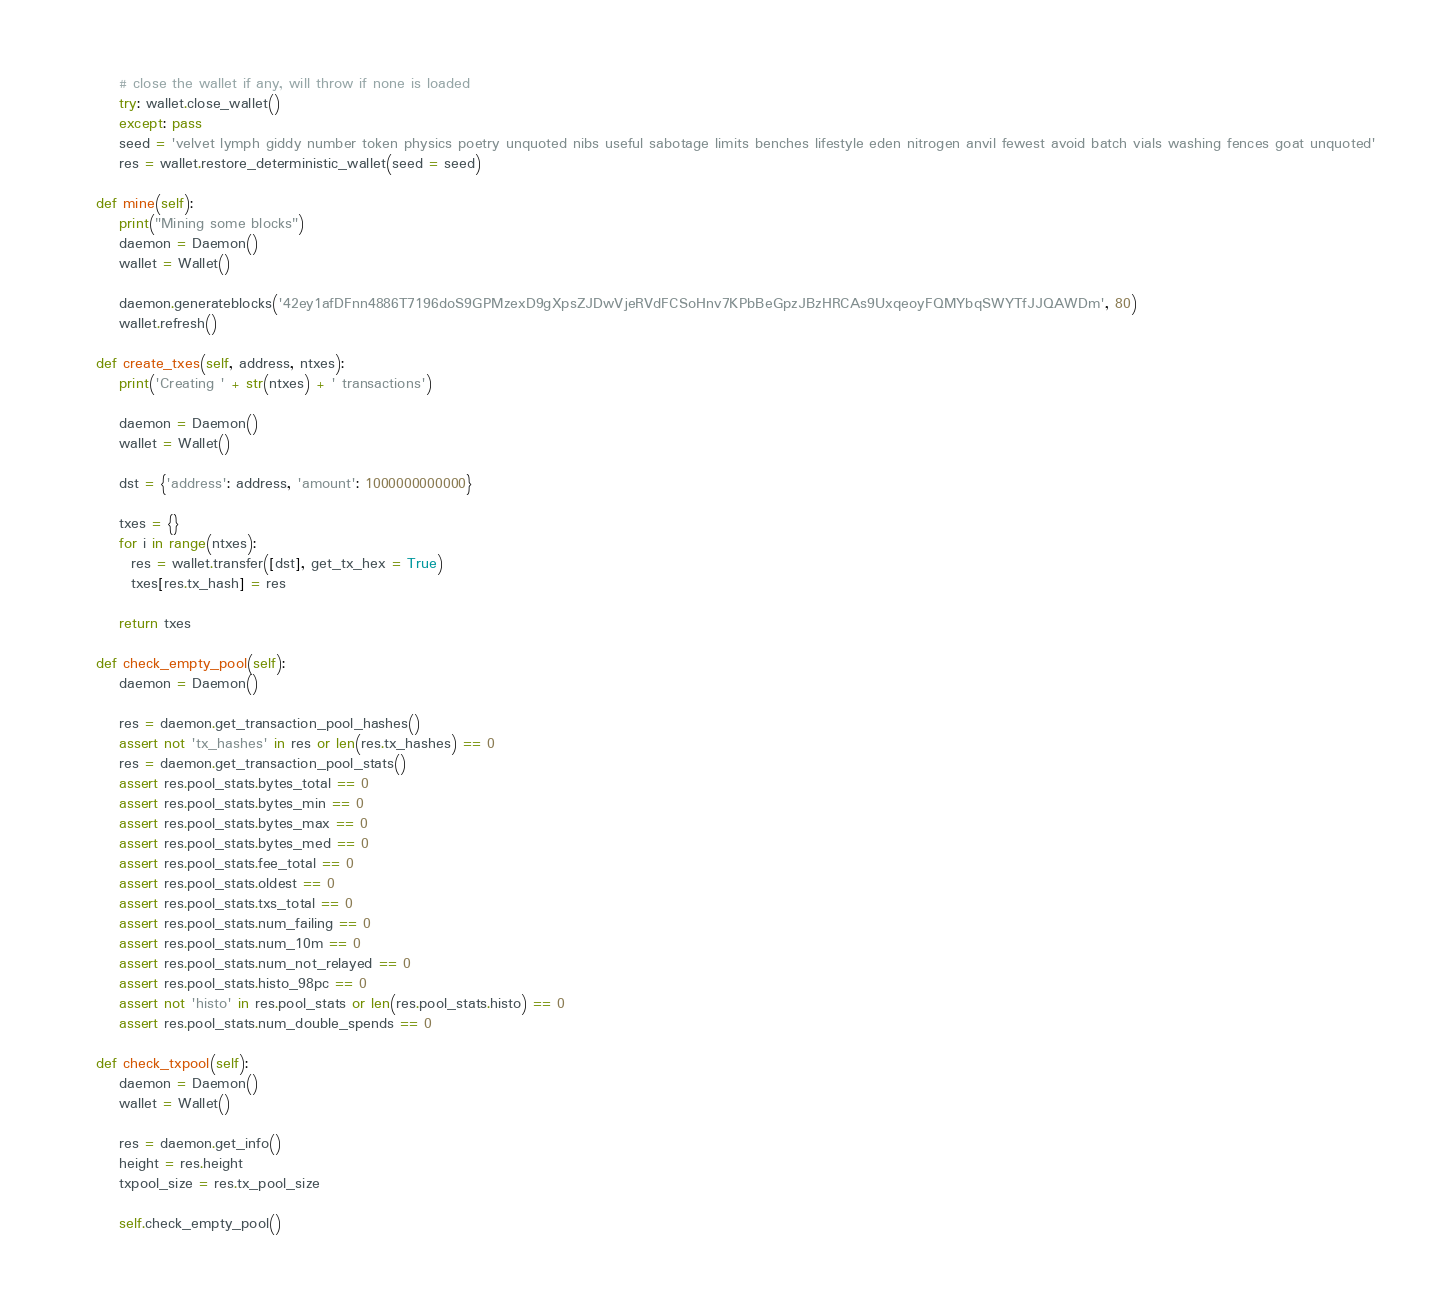Convert code to text. <code><loc_0><loc_0><loc_500><loc_500><_Python_>        # close the wallet if any, will throw if none is loaded
        try: wallet.close_wallet()
        except: pass
        seed = 'velvet lymph giddy number token physics poetry unquoted nibs useful sabotage limits benches lifestyle eden nitrogen anvil fewest avoid batch vials washing fences goat unquoted'
        res = wallet.restore_deterministic_wallet(seed = seed)

    def mine(self):
        print("Mining some blocks")
        daemon = Daemon()
        wallet = Wallet()

        daemon.generateblocks('42ey1afDFnn4886T7196doS9GPMzexD9gXpsZJDwVjeRVdFCSoHnv7KPbBeGpzJBzHRCAs9UxqeoyFQMYbqSWYTfJJQAWDm', 80)
        wallet.refresh()

    def create_txes(self, address, ntxes):
        print('Creating ' + str(ntxes) + ' transactions')

        daemon = Daemon()
        wallet = Wallet()

        dst = {'address': address, 'amount': 1000000000000}

        txes = {}
        for i in range(ntxes):
          res = wallet.transfer([dst], get_tx_hex = True)
          txes[res.tx_hash] = res

        return txes

    def check_empty_pool(self):
        daemon = Daemon()

        res = daemon.get_transaction_pool_hashes()
        assert not 'tx_hashes' in res or len(res.tx_hashes) == 0
        res = daemon.get_transaction_pool_stats()
        assert res.pool_stats.bytes_total == 0
        assert res.pool_stats.bytes_min == 0
        assert res.pool_stats.bytes_max == 0
        assert res.pool_stats.bytes_med == 0
        assert res.pool_stats.fee_total == 0
        assert res.pool_stats.oldest == 0
        assert res.pool_stats.txs_total == 0
        assert res.pool_stats.num_failing == 0
        assert res.pool_stats.num_10m == 0
        assert res.pool_stats.num_not_relayed == 0
        assert res.pool_stats.histo_98pc == 0
        assert not 'histo' in res.pool_stats or len(res.pool_stats.histo) == 0
        assert res.pool_stats.num_double_spends == 0

    def check_txpool(self):
        daemon = Daemon()
        wallet = Wallet()

        res = daemon.get_info()
        height = res.height
        txpool_size = res.tx_pool_size

        self.check_empty_pool()
</code> 